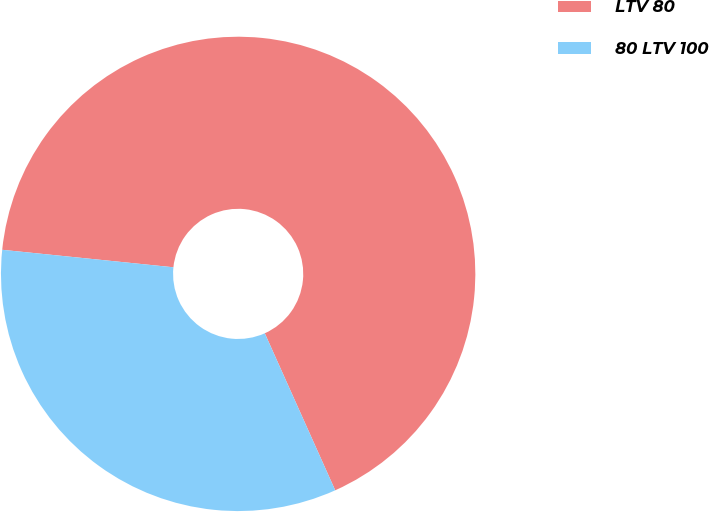<chart> <loc_0><loc_0><loc_500><loc_500><pie_chart><fcel>LTV 80<fcel>80 LTV 100<nl><fcel>66.67%<fcel>33.33%<nl></chart> 